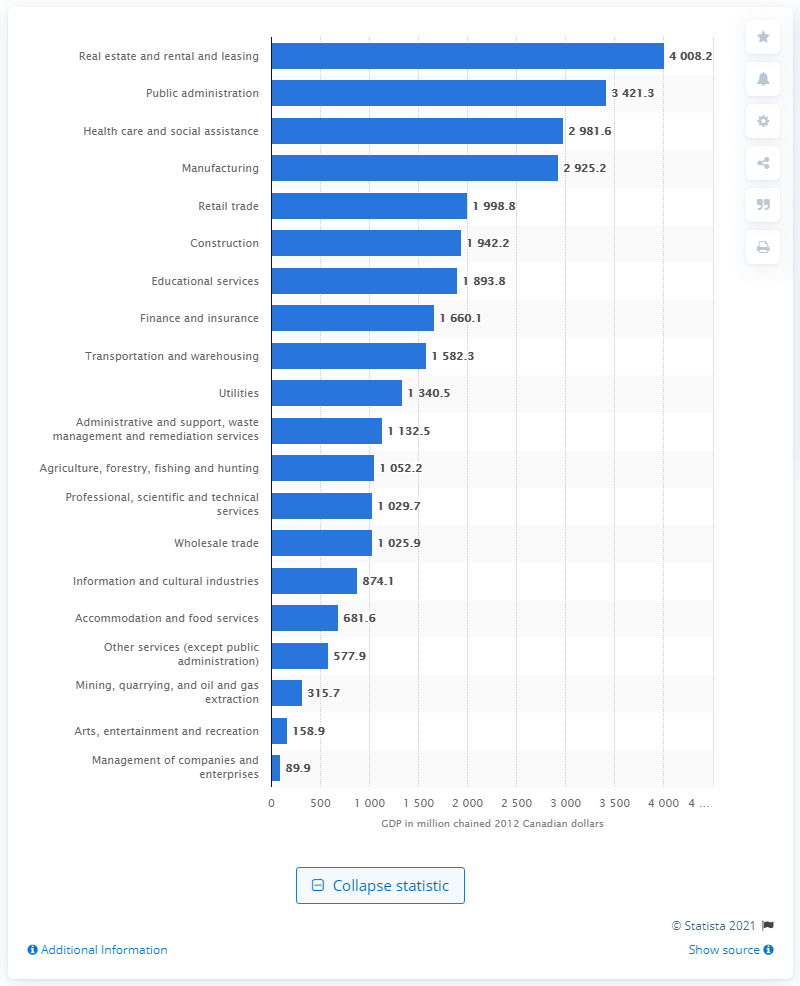Draw attention to some important aspects in this diagram. In 2012, the GDP of the construction industry in New Brunswick was estimated to be 1942.2 Canadian dollars. 